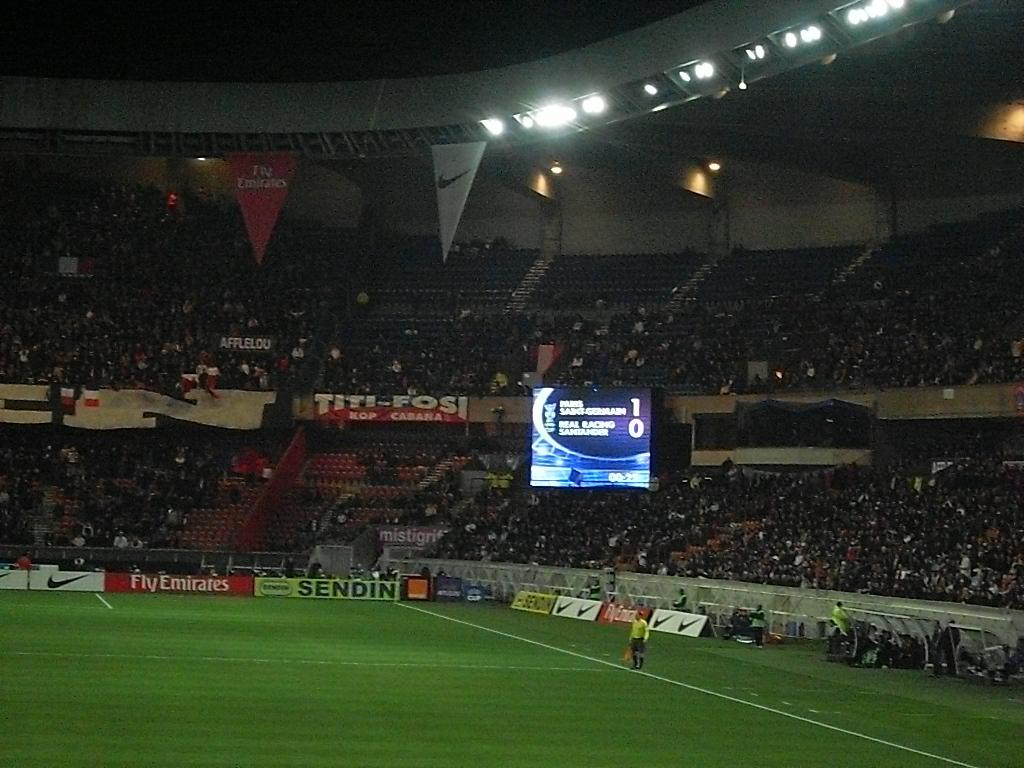<image>
Relay a brief, clear account of the picture shown. A stadium full of people watching a soccer game, with billboard for Fly Emirates and Nike displayed on the field. 